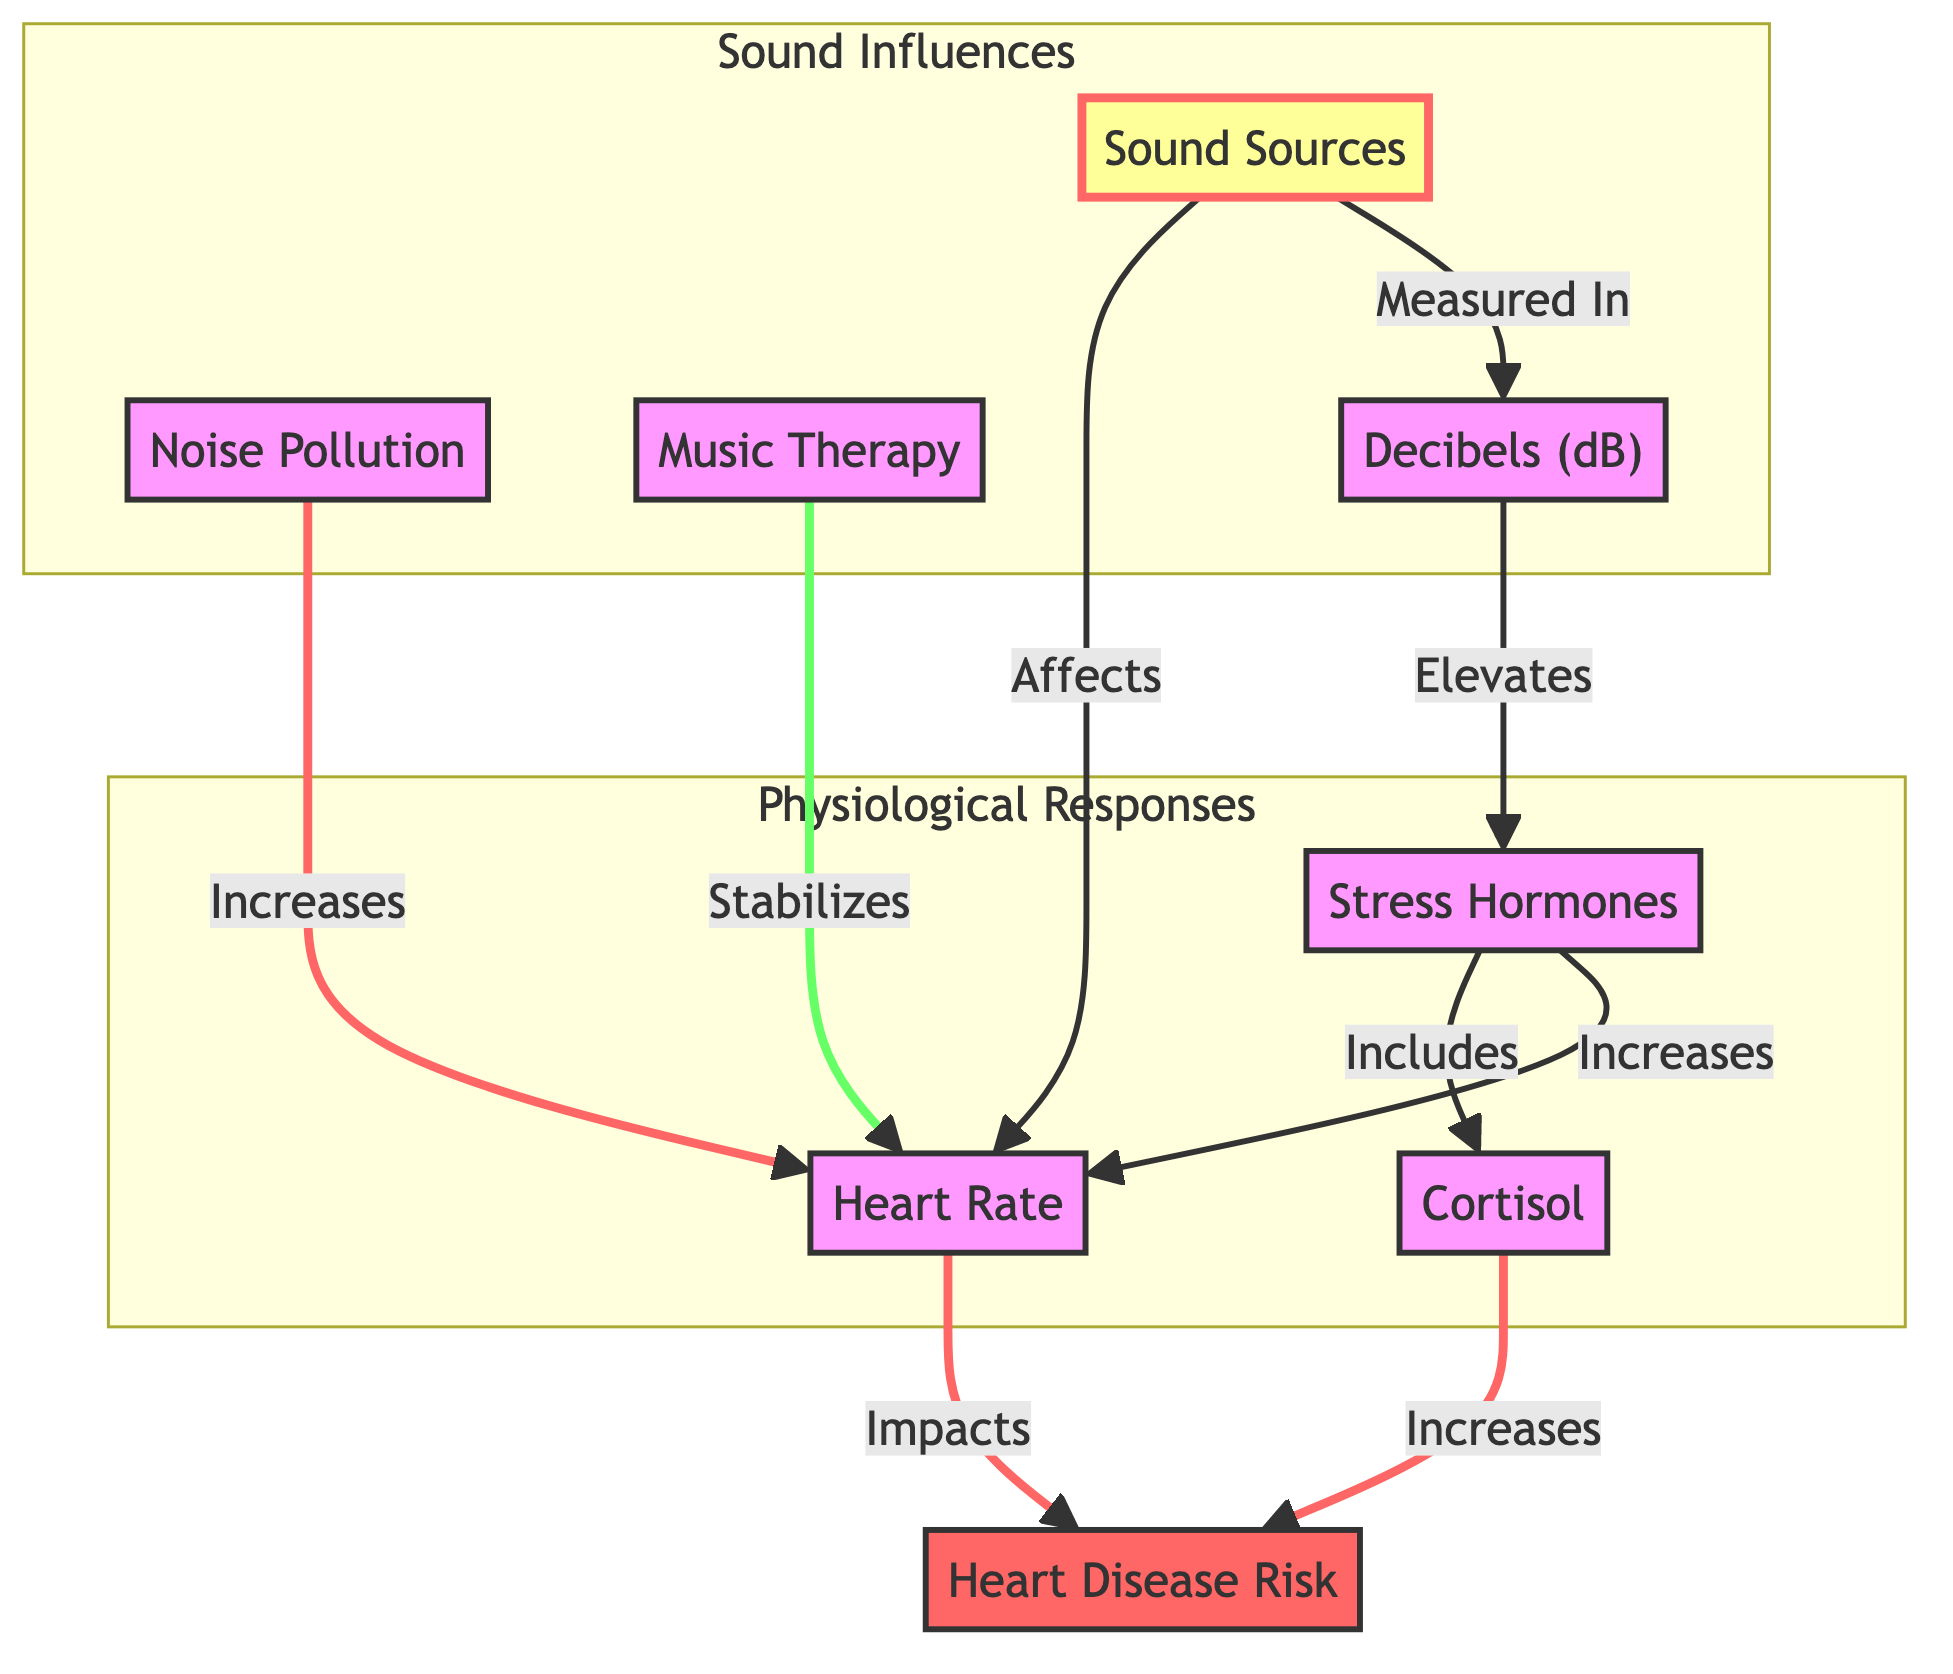What are the main sound sources influencing heart rate? The diagram outlines "Sound Sources" as the initial node, which includes categories like "Noise Pollution" and "Music Therapy" that directly affect heart rate.
Answer: Sound Sources What relationship does noise pollution have with heart rate? According to the diagram, "Noise Pollution" is shown to directly increase heart rate, which is indicated by the arrow connecting the two nodes.
Answer: Increases What effect does music therapy have on heart rate? The diagram indicates that "Music Therapy" serves the function of stabilizing heart rate as depicted by the directional linkage from "Music Therapy" to "Heart Rate."
Answer: Stabilizes How is heart disease risk affected by heart rate? The flowchart illustrates that "Heart Rate" imparts an impact on "Heart Disease Risk," establishing a direct relationship between these two nodes.
Answer: Impacts What stress hormone is mentioned in the diagram? The diagram lists "Cortisol" as a specific stress hormone, highlighted under the "Stress Hormones" node.
Answer: Cortisol What is the role of decibels in relation to stress hormones? In the diagram, "Decibels" are shown to elevate "Stress Hormones," indicating a causal relationship where higher sound levels can increase stress hormone levels.
Answer: Elevates What element is considered a risk factor for heart disease? The diagram identifies "Heart Disease Risk" as a linked outcome influenced by growing levels of "Cortisol," thus highlighting it as a major risk factor.
Answer: Heart Disease Risk How are stress hormones connected to heart rate? The diagram shows that "Stress Hormones" directly increase "Heart Rate," establishing a biological connection between stress factors and cardiovascular effects.
Answer: Increases What are the components of the "Physiological Responses" subgraph? The "Physiological Responses" subgraph contains the nodes "Heart Rate," "Stress Hormones," and "Cortisol," indicating the biological responses related to sound effects.
Answer: Heart Rate, Stress Hormones, Cortisol 